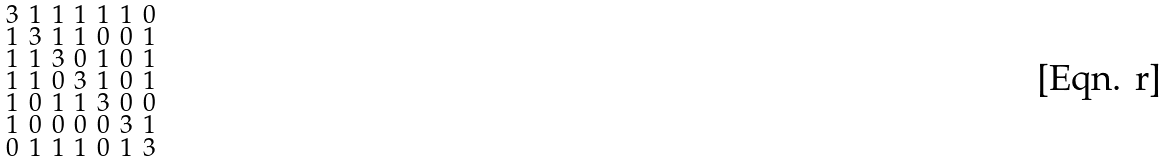Convert formula to latex. <formula><loc_0><loc_0><loc_500><loc_500>\begin{smallmatrix} 3 & 1 & 1 & 1 & 1 & 1 & 0 \\ 1 & 3 & 1 & 1 & 0 & 0 & 1 \\ 1 & 1 & 3 & 0 & 1 & 0 & 1 \\ 1 & 1 & 0 & 3 & 1 & 0 & 1 \\ 1 & 0 & 1 & 1 & 3 & 0 & 0 \\ 1 & 0 & 0 & 0 & 0 & 3 & 1 \\ 0 & 1 & 1 & 1 & 0 & 1 & 3 \end{smallmatrix}</formula> 